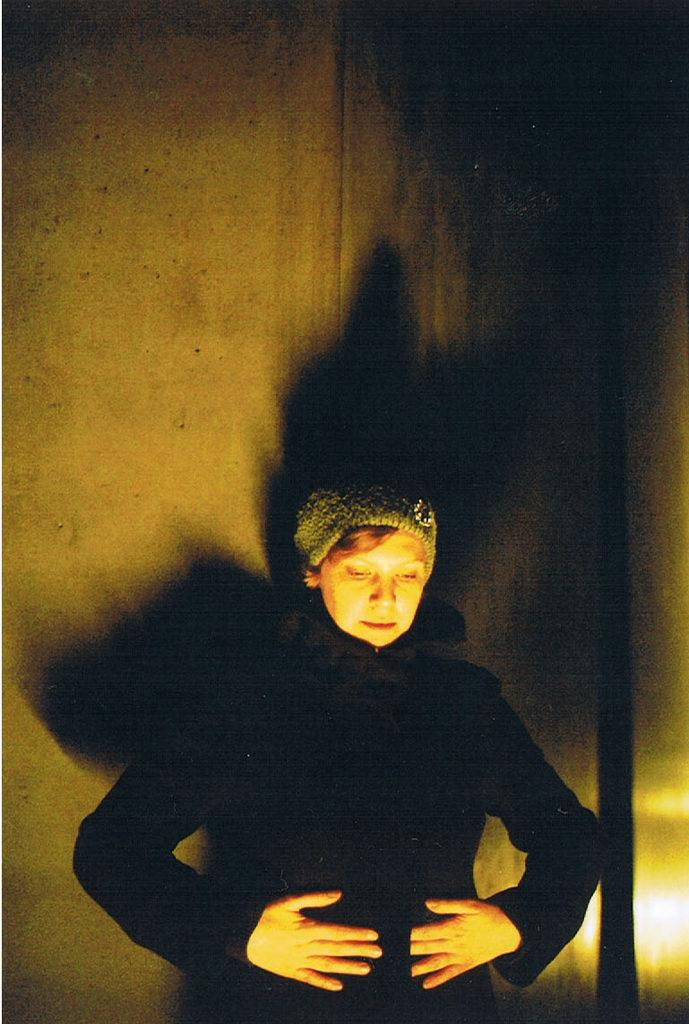Who is the main subject in the image? There is a woman in the image. What is the woman wearing on her head? The woman is wearing a cap on her head. What type of clothing is the woman wearing? The woman is wearing a black coat. What can be seen in the background of the image? There is a wall visible in the background of the image. What type of plane is the woman flying in the image? There is no plane present in the image; it features a woman wearing a cap and a black coat with a wall visible in the background. Can you read the note the woman is holding in the image? There is no note visible in the image; the woman is not holding anything. 